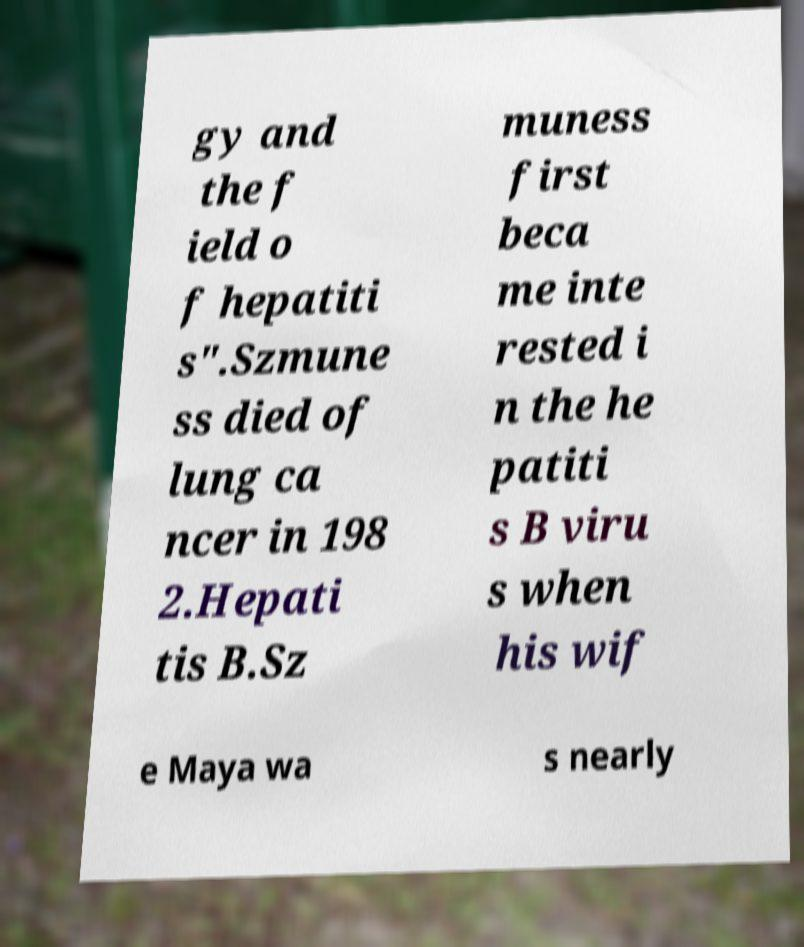Please read and relay the text visible in this image. What does it say? gy and the f ield o f hepatiti s".Szmune ss died of lung ca ncer in 198 2.Hepati tis B.Sz muness first beca me inte rested i n the he patiti s B viru s when his wif e Maya wa s nearly 